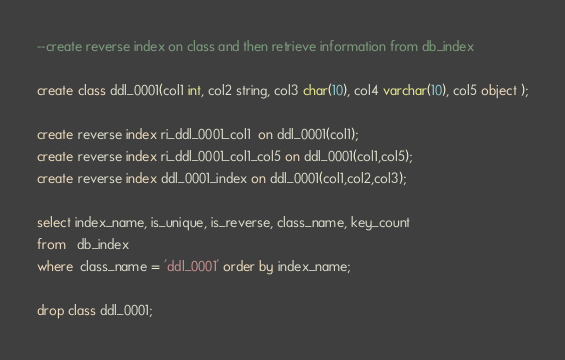<code> <loc_0><loc_0><loc_500><loc_500><_SQL_>--create reverse index on class and then retrieve information from db_index

create class ddl_0001(col1 int, col2 string, col3 char(10), col4 varchar(10), col5 object );

create reverse index ri_ddl_0001_col1  on ddl_0001(col1);
create reverse index ri_ddl_0001_col1_col5 on ddl_0001(col1,col5);
create reverse index ddl_0001_index on ddl_0001(col1,col2,col3);

select index_name, is_unique, is_reverse, class_name, key_count
from   db_index
where  class_name = 'ddl_0001' order by index_name;

drop class ddl_0001;
</code> 